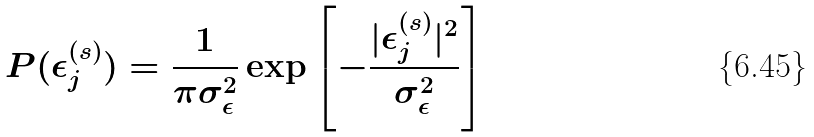<formula> <loc_0><loc_0><loc_500><loc_500>P ( \epsilon _ { j } ^ { ( s ) } ) = \frac { 1 } { \pi \sigma _ { \epsilon } ^ { 2 } } \exp { \left [ - \frac { | \epsilon _ { j } ^ { ( s ) } | ^ { 2 } } { \sigma _ { \epsilon } ^ { 2 } } \right ] }</formula> 